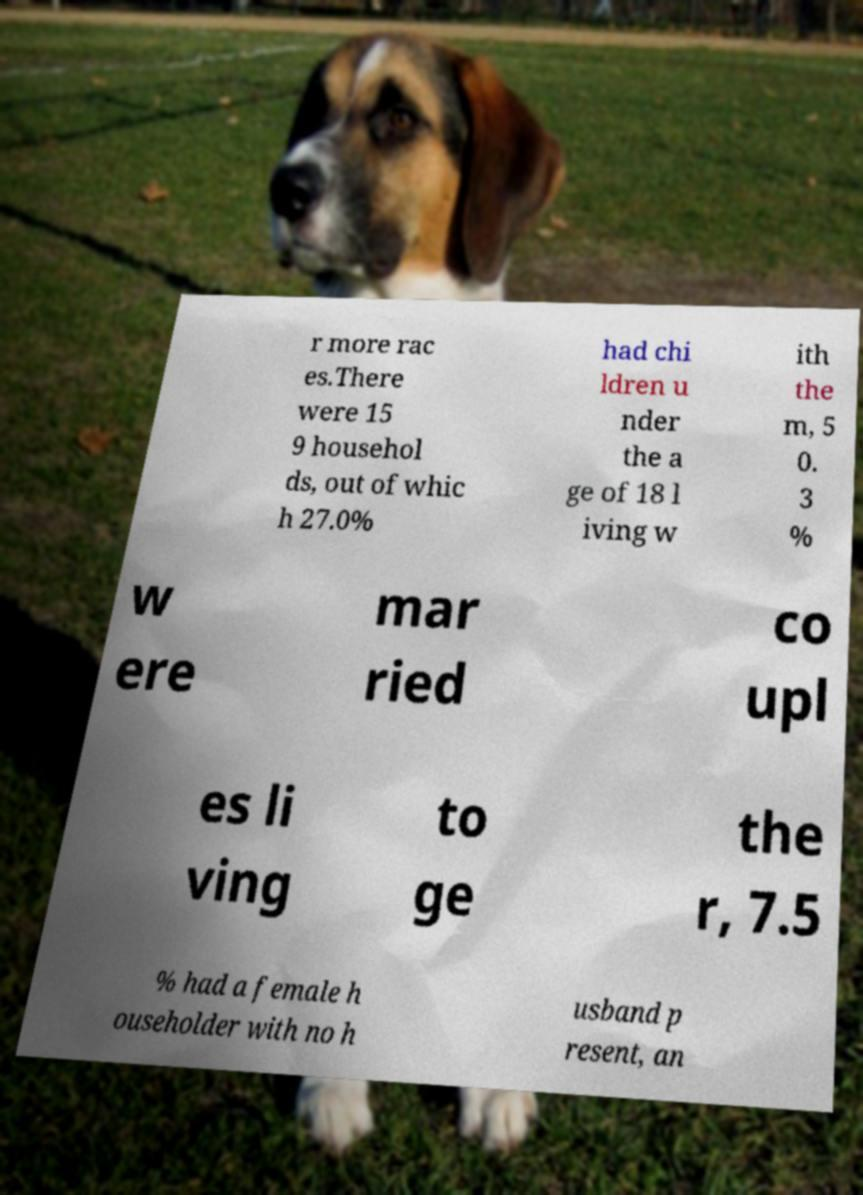What messages or text are displayed in this image? I need them in a readable, typed format. r more rac es.There were 15 9 househol ds, out of whic h 27.0% had chi ldren u nder the a ge of 18 l iving w ith the m, 5 0. 3 % w ere mar ried co upl es li ving to ge the r, 7.5 % had a female h ouseholder with no h usband p resent, an 